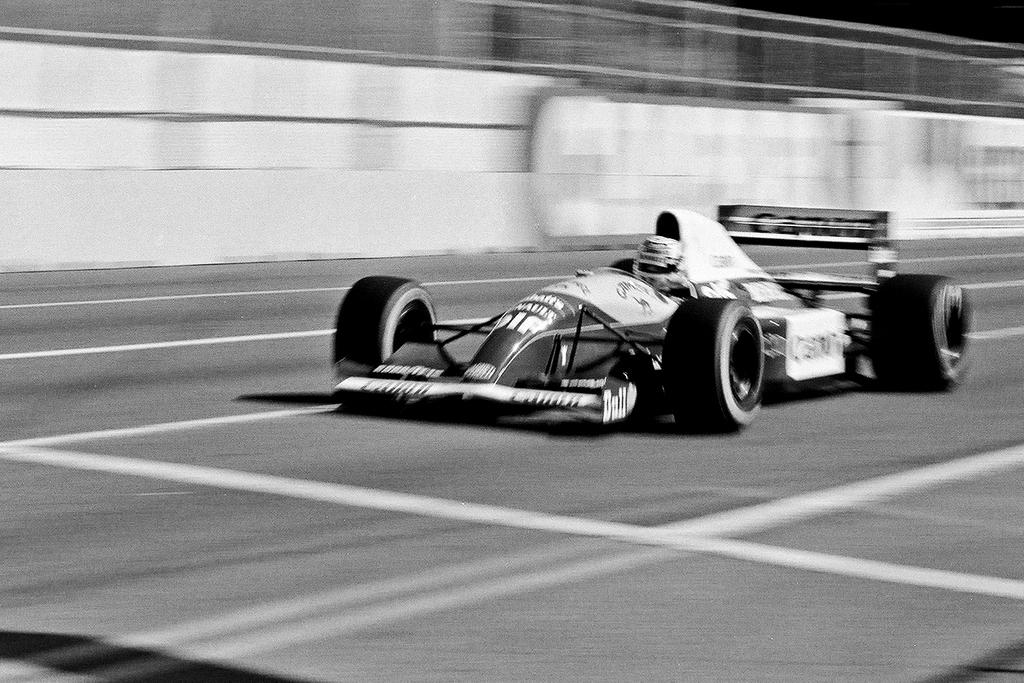What can be observed about the background of the image? The background of the image is blurred. What is present on the road in the image? There is a vehicle on the road in the image. What color scheme is used in the image? The image is in black and white. What type of punishment is being administered in the image? There is no punishment being administered in the image; it features a vehicle on the road with a blurred background in black and white. Can you describe the fight taking place in the image? There is no fight present in the image; it only shows a vehicle on the road with a blurred background in black and white. 